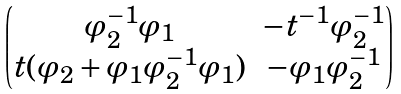Convert formula to latex. <formula><loc_0><loc_0><loc_500><loc_500>\begin{pmatrix} \varphi _ { 2 } ^ { - 1 } \varphi _ { 1 } & - t ^ { - 1 } \varphi _ { 2 } ^ { - 1 } \\ t ( \varphi _ { 2 } + \varphi _ { 1 } \varphi _ { 2 } ^ { - 1 } \varphi _ { 1 } ) & - \varphi _ { 1 } \varphi _ { 2 } ^ { - 1 } \end{pmatrix}</formula> 